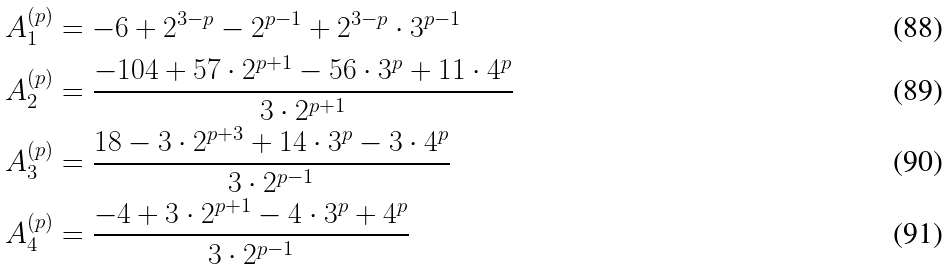<formula> <loc_0><loc_0><loc_500><loc_500>A _ { 1 } ^ { ( p ) } & = - 6 + 2 ^ { 3 - p } - 2 ^ { p - 1 } + 2 ^ { 3 - p } \cdot 3 ^ { p - 1 } \\ A _ { 2 } ^ { ( p ) } & = \frac { - 1 0 4 + 5 7 \cdot 2 ^ { p + 1 } - 5 6 \cdot 3 ^ { p } + 1 1 \cdot 4 ^ { p } } { 3 \cdot 2 ^ { p + 1 } } \\ A _ { 3 } ^ { ( p ) } & = \frac { 1 8 - 3 \cdot 2 ^ { p + 3 } + 1 4 \cdot 3 ^ { p } - 3 \cdot 4 ^ { p } } { 3 \cdot 2 ^ { p - 1 } } \\ A _ { 4 } ^ { ( p ) } & = \frac { - 4 + 3 \cdot 2 ^ { p + 1 } - 4 \cdot 3 ^ { p } + 4 ^ { p } } { 3 \cdot 2 ^ { p - 1 } }</formula> 